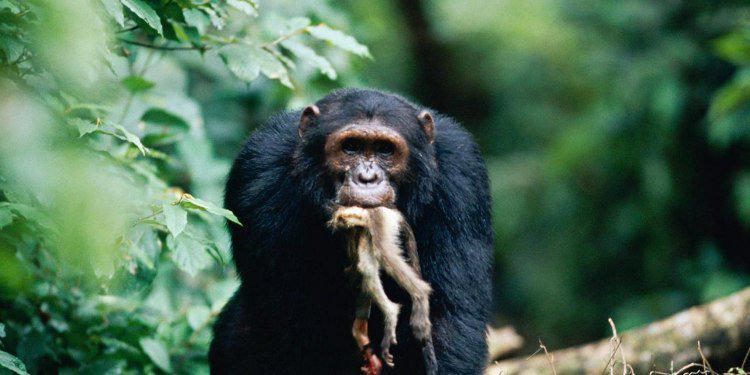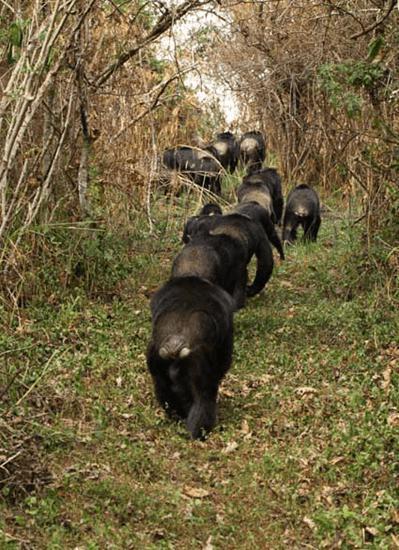The first image is the image on the left, the second image is the image on the right. Assess this claim about the two images: "In one image there is a lone chimpanzee eating meat in the center of the image.". Correct or not? Answer yes or no. Yes. The first image is the image on the left, the second image is the image on the right. Assess this claim about the two images: "there is a single chimp holding animal parts". Correct or not? Answer yes or no. Yes. 